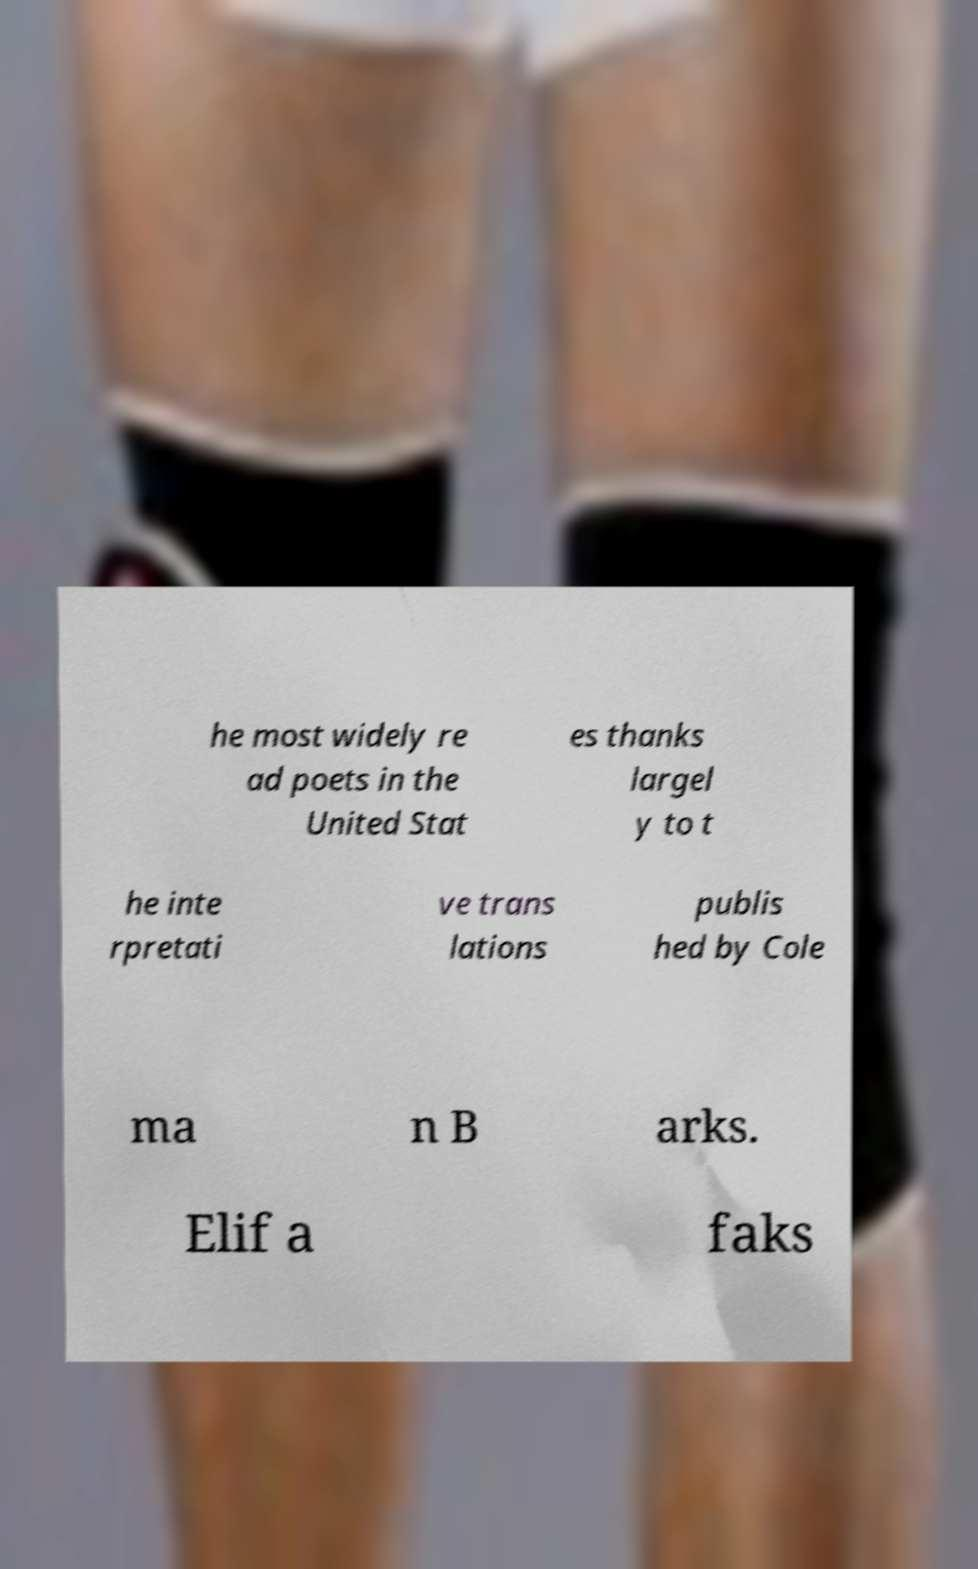Could you assist in decoding the text presented in this image and type it out clearly? he most widely re ad poets in the United Stat es thanks largel y to t he inte rpretati ve trans lations publis hed by Cole ma n B arks. Elif a faks 